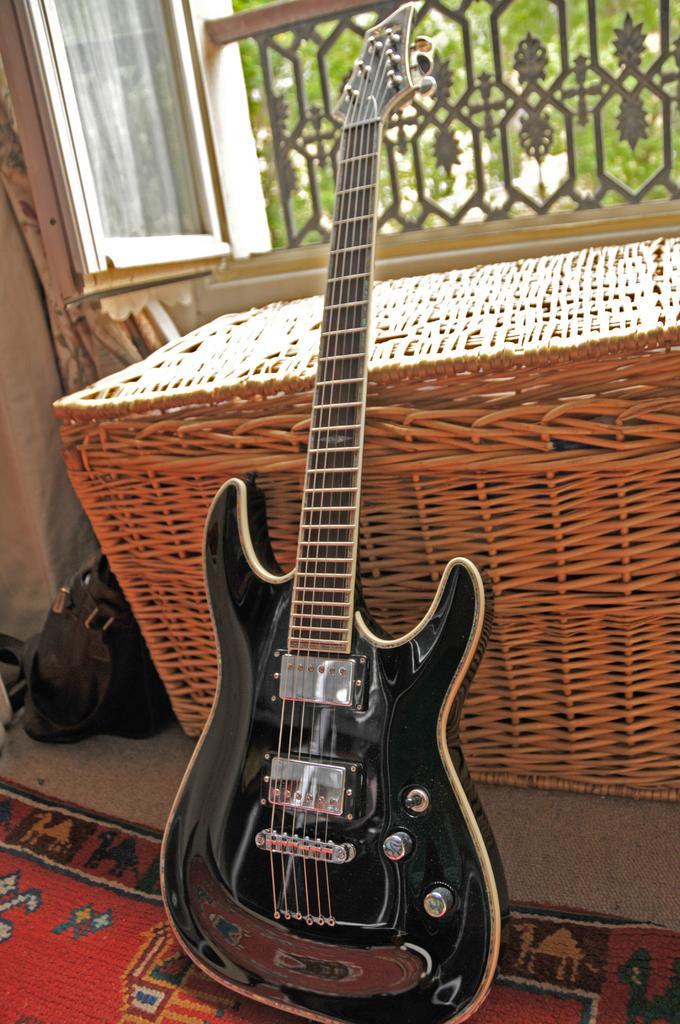Can you describe this image briefly? It is a guitar, in the right side it is a window. 